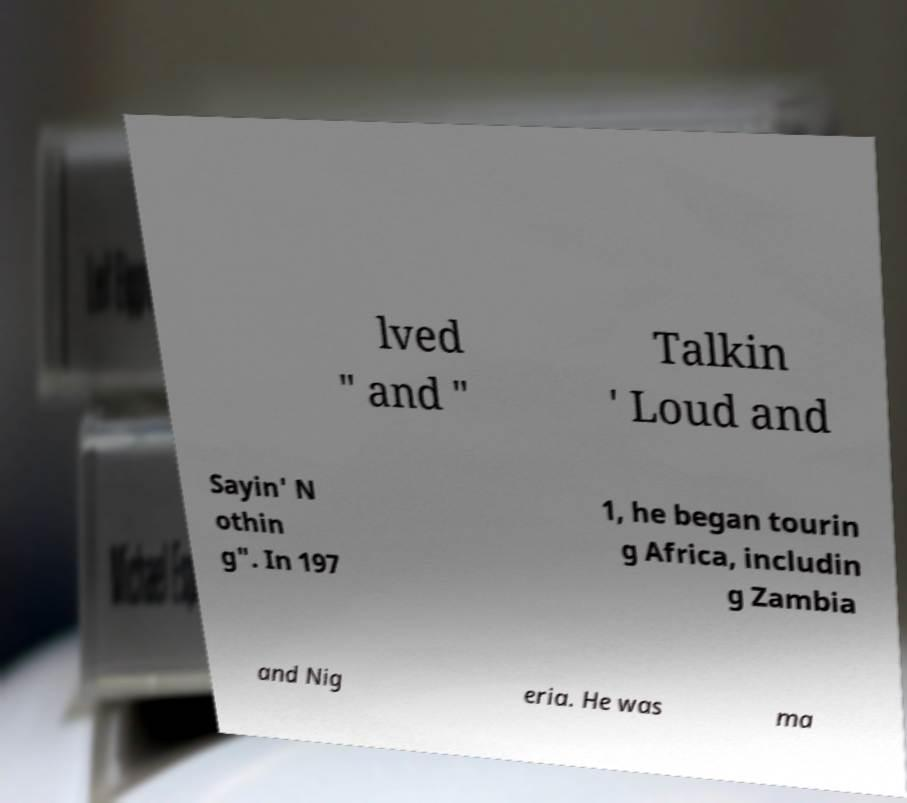I need the written content from this picture converted into text. Can you do that? lved " and " Talkin ' Loud and Sayin' N othin g". In 197 1, he began tourin g Africa, includin g Zambia and Nig eria. He was ma 